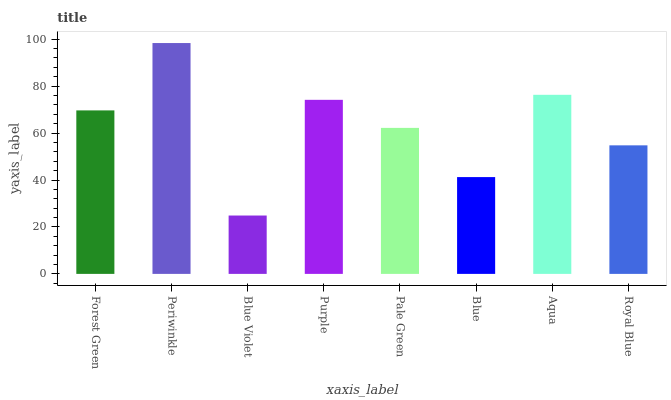Is Blue Violet the minimum?
Answer yes or no. Yes. Is Periwinkle the maximum?
Answer yes or no. Yes. Is Periwinkle the minimum?
Answer yes or no. No. Is Blue Violet the maximum?
Answer yes or no. No. Is Periwinkle greater than Blue Violet?
Answer yes or no. Yes. Is Blue Violet less than Periwinkle?
Answer yes or no. Yes. Is Blue Violet greater than Periwinkle?
Answer yes or no. No. Is Periwinkle less than Blue Violet?
Answer yes or no. No. Is Forest Green the high median?
Answer yes or no. Yes. Is Pale Green the low median?
Answer yes or no. Yes. Is Purple the high median?
Answer yes or no. No. Is Forest Green the low median?
Answer yes or no. No. 